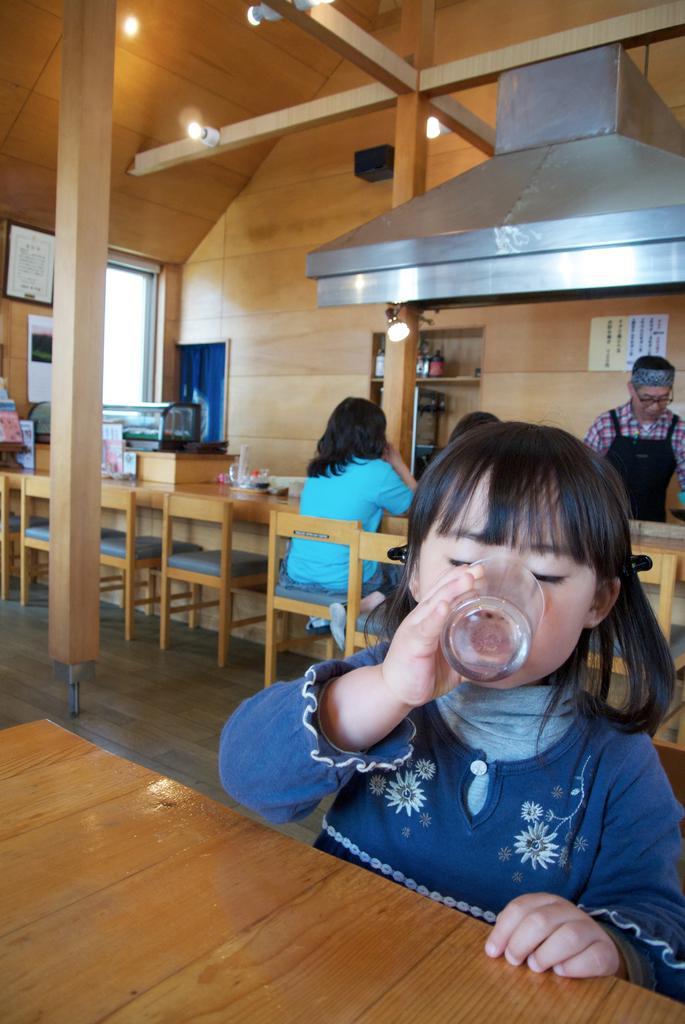In one or two sentences, can you explain what this image depicts? These persons are sitting on a chair. This kid is drinking water from this glass. In-front of this kid there is a table. On top there are lights. This man is standing. On wall there is a poster and photo. 